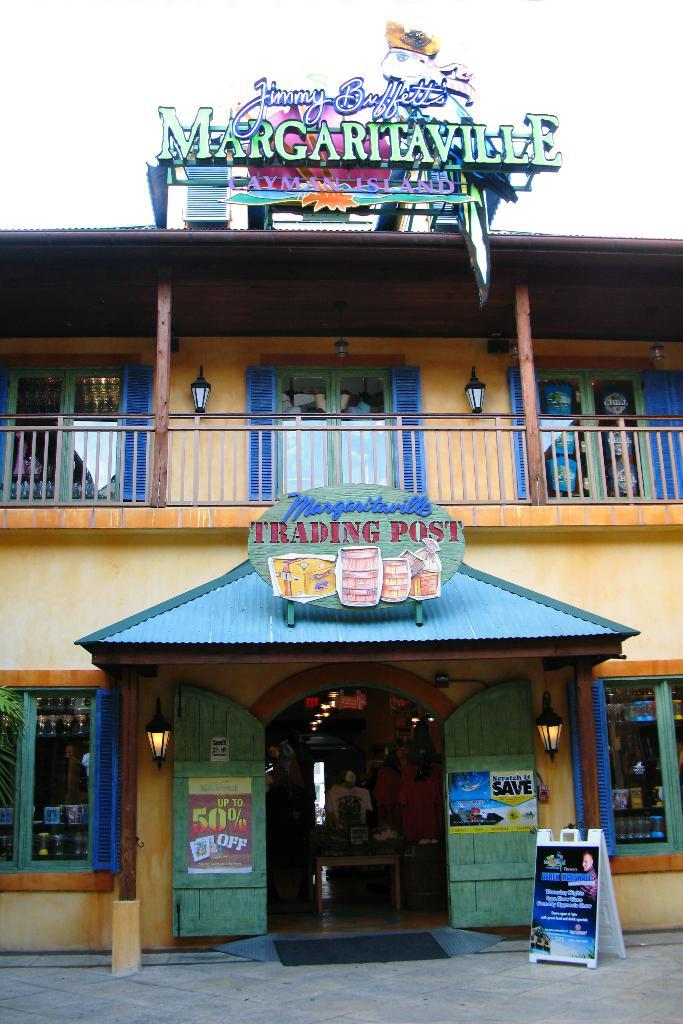What is the name of this restaurant?
Make the answer very short. Margaritaville. What is the kind of post?
Make the answer very short. Trading. 